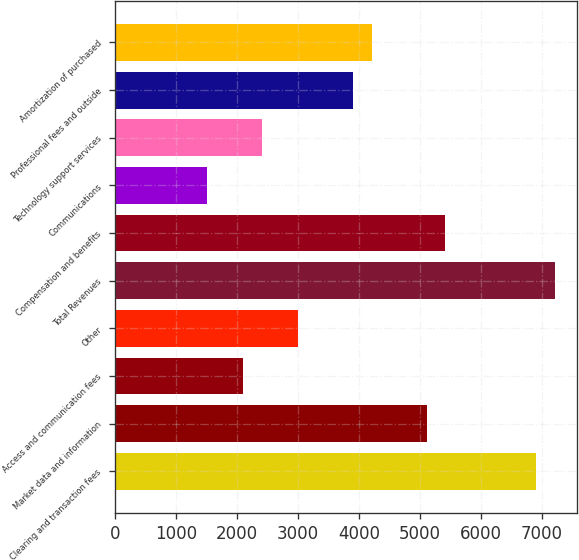Convert chart. <chart><loc_0><loc_0><loc_500><loc_500><bar_chart><fcel>Clearing and transaction fees<fcel>Market data and information<fcel>Access and communication fees<fcel>Other<fcel>Total Revenues<fcel>Compensation and benefits<fcel>Communications<fcel>Technology support services<fcel>Professional fees and outside<fcel>Amortization of purchased<nl><fcel>6907.73<fcel>5105.87<fcel>2102.77<fcel>3003.7<fcel>7208.04<fcel>5406.18<fcel>1502.15<fcel>2403.08<fcel>3904.63<fcel>4204.94<nl></chart> 